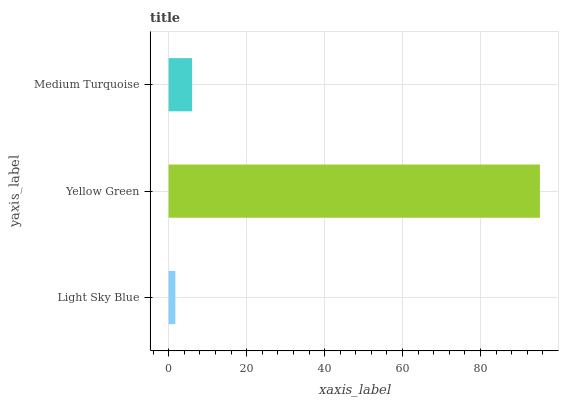Is Light Sky Blue the minimum?
Answer yes or no. Yes. Is Yellow Green the maximum?
Answer yes or no. Yes. Is Medium Turquoise the minimum?
Answer yes or no. No. Is Medium Turquoise the maximum?
Answer yes or no. No. Is Yellow Green greater than Medium Turquoise?
Answer yes or no. Yes. Is Medium Turquoise less than Yellow Green?
Answer yes or no. Yes. Is Medium Turquoise greater than Yellow Green?
Answer yes or no. No. Is Yellow Green less than Medium Turquoise?
Answer yes or no. No. Is Medium Turquoise the high median?
Answer yes or no. Yes. Is Medium Turquoise the low median?
Answer yes or no. Yes. Is Light Sky Blue the high median?
Answer yes or no. No. Is Light Sky Blue the low median?
Answer yes or no. No. 